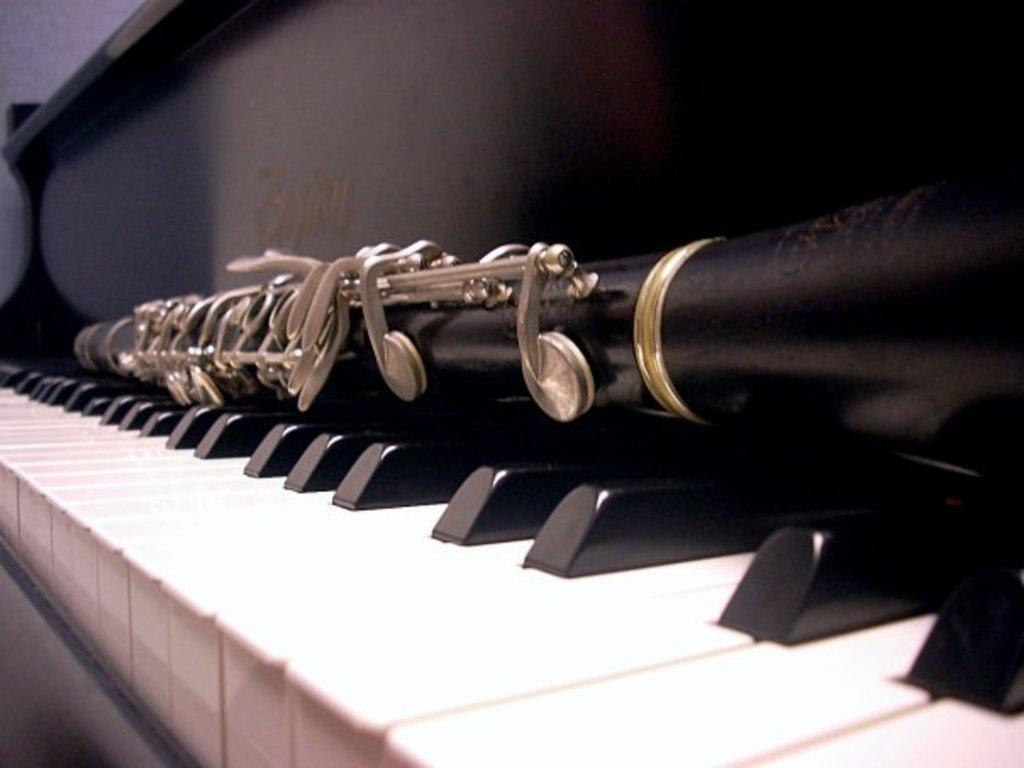What is the main object in the image? The main object in the image is a keyboard. What colors are the buttons on the keyboard? The keyboard has white and black color buttons. How does the sheet of paper interact with the keyboard in the image? There is no sheet of paper present in the image; it only features a keyboard with white and black color buttons. 